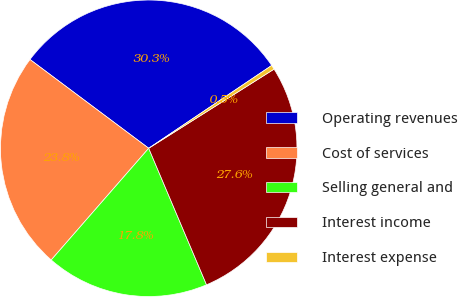Convert chart to OTSL. <chart><loc_0><loc_0><loc_500><loc_500><pie_chart><fcel>Operating revenues<fcel>Cost of services<fcel>Selling general and<fcel>Interest income<fcel>Interest expense<nl><fcel>30.35%<fcel>23.8%<fcel>17.8%<fcel>27.59%<fcel>0.47%<nl></chart> 